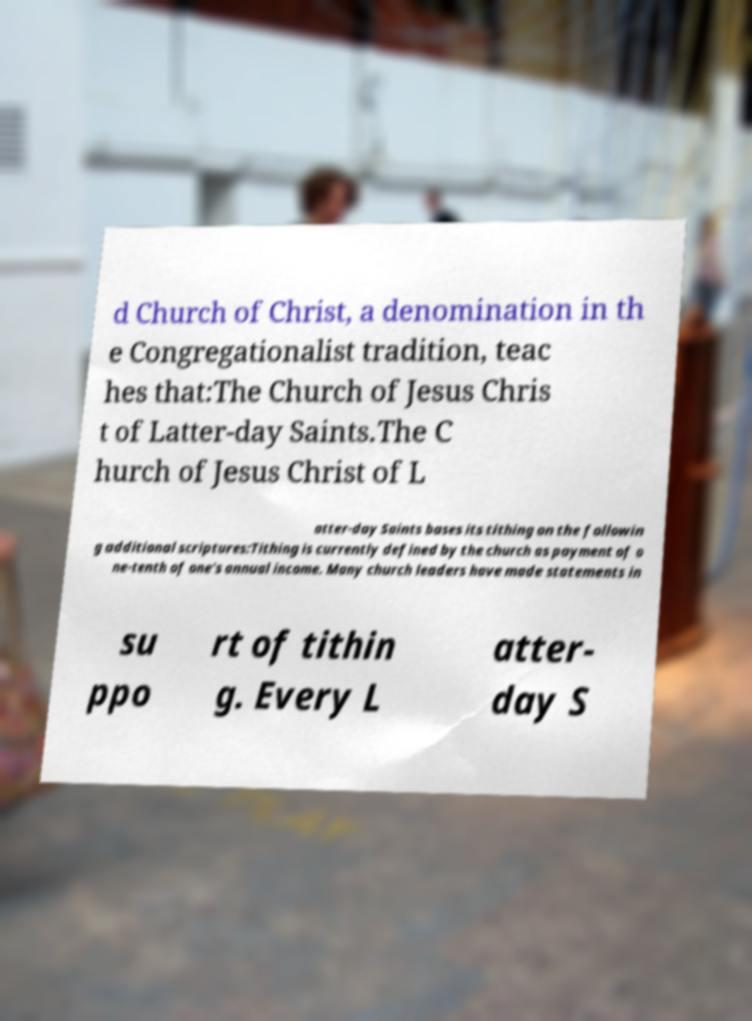There's text embedded in this image that I need extracted. Can you transcribe it verbatim? d Church of Christ, a denomination in th e Congregationalist tradition, teac hes that:The Church of Jesus Chris t of Latter-day Saints.The C hurch of Jesus Christ of L atter-day Saints bases its tithing on the followin g additional scriptures:Tithing is currently defined by the church as payment of o ne-tenth of one's annual income. Many church leaders have made statements in su ppo rt of tithin g. Every L atter- day S 